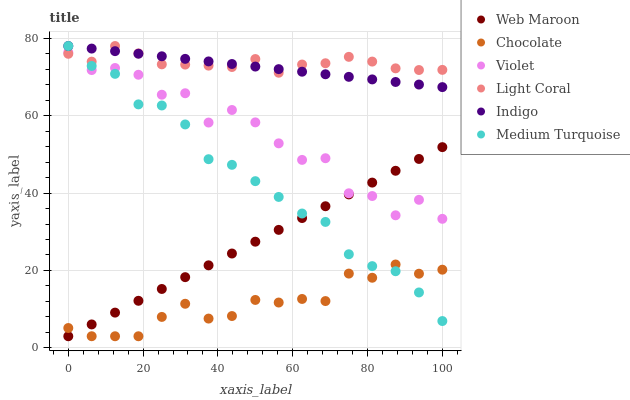Does Chocolate have the minimum area under the curve?
Answer yes or no. Yes. Does Light Coral have the maximum area under the curve?
Answer yes or no. Yes. Does Web Maroon have the minimum area under the curve?
Answer yes or no. No. Does Web Maroon have the maximum area under the curve?
Answer yes or no. No. Is Web Maroon the smoothest?
Answer yes or no. Yes. Is Violet the roughest?
Answer yes or no. Yes. Is Chocolate the smoothest?
Answer yes or no. No. Is Chocolate the roughest?
Answer yes or no. No. Does Web Maroon have the lowest value?
Answer yes or no. Yes. Does Light Coral have the lowest value?
Answer yes or no. No. Does Medium Turquoise have the highest value?
Answer yes or no. Yes. Does Web Maroon have the highest value?
Answer yes or no. No. Is Web Maroon less than Indigo?
Answer yes or no. Yes. Is Light Coral greater than Web Maroon?
Answer yes or no. Yes. Does Web Maroon intersect Violet?
Answer yes or no. Yes. Is Web Maroon less than Violet?
Answer yes or no. No. Is Web Maroon greater than Violet?
Answer yes or no. No. Does Web Maroon intersect Indigo?
Answer yes or no. No. 